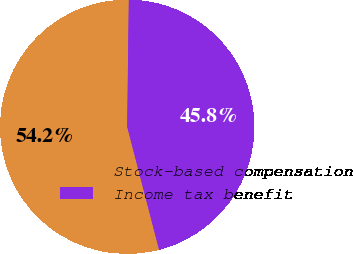Convert chart. <chart><loc_0><loc_0><loc_500><loc_500><pie_chart><fcel>Stock-based compensation<fcel>Income tax benefit<nl><fcel>54.24%<fcel>45.76%<nl></chart> 